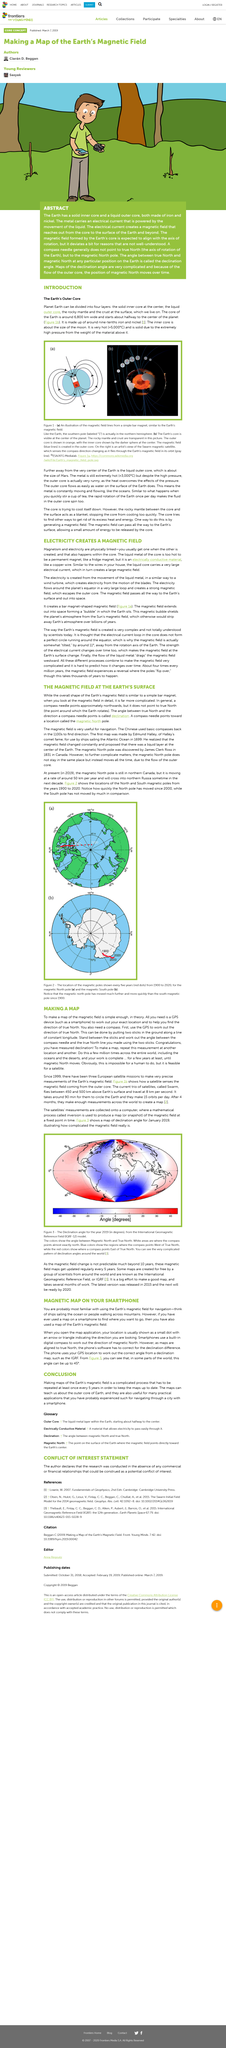Give some essential details in this illustration. It is possible to divide the planet Earth into four distinct layers based on their distinct characteristics, such as composition and density. The white areas in Figure 3 indicate approximately northward direction. The magnetic field of the Earth experiences approximately four reversals every million years on average. The creation of electricity in the Earth's core is a result of the movement of liquid metal. Since 1900, the magnetic North Pole has moved much further and more quickly than the South Magnetic Pole, indicating a rapid change in the Earth's magnetic field. 